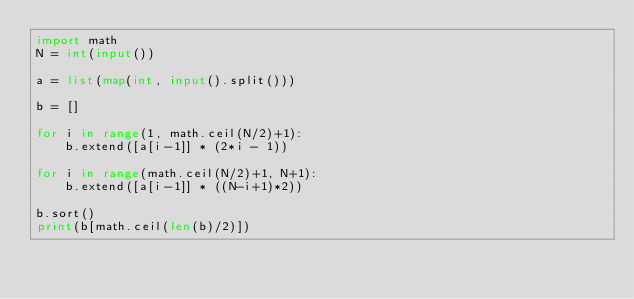Convert code to text. <code><loc_0><loc_0><loc_500><loc_500><_Python_>import math
N = int(input())

a = list(map(int, input().split()))

b = []

for i in range(1, math.ceil(N/2)+1):
    b.extend([a[i-1]] * (2*i - 1))

for i in range(math.ceil(N/2)+1, N+1):
    b.extend([a[i-1]] * ((N-i+1)*2))

b.sort()
print(b[math.ceil(len(b)/2)])
</code> 